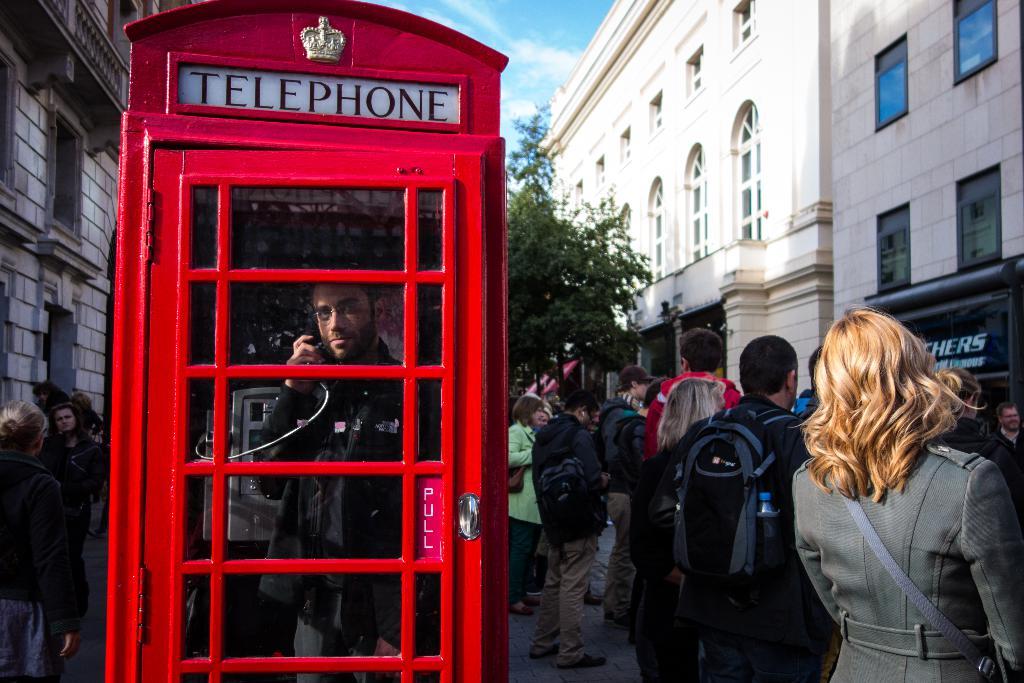What's above the door?
Your answer should be compact. Telephone. 